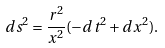Convert formula to latex. <formula><loc_0><loc_0><loc_500><loc_500>d s ^ { 2 } = \frac { r ^ { 2 } } { x ^ { 2 } } ( - d t ^ { 2 } + d x ^ { 2 } ) .</formula> 